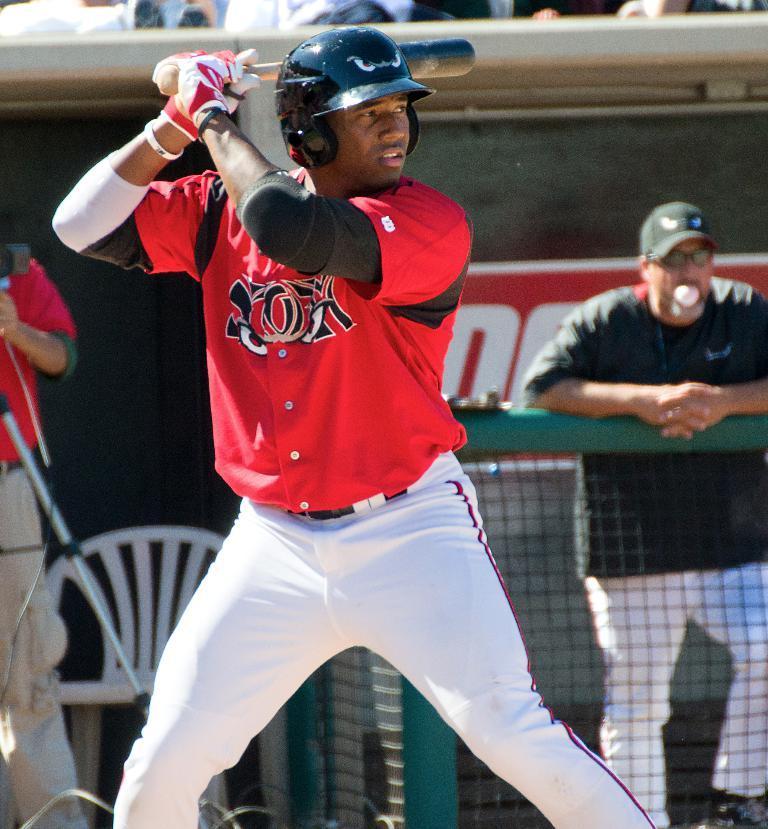Could you give a brief overview of what you see in this image? In the middle of the image a person is standing and holding a baseball bat. Behind him we can see fencing. Behind the fencing few people are standing and we can see some chairs and banners. At the top of the image few people are sitting. 